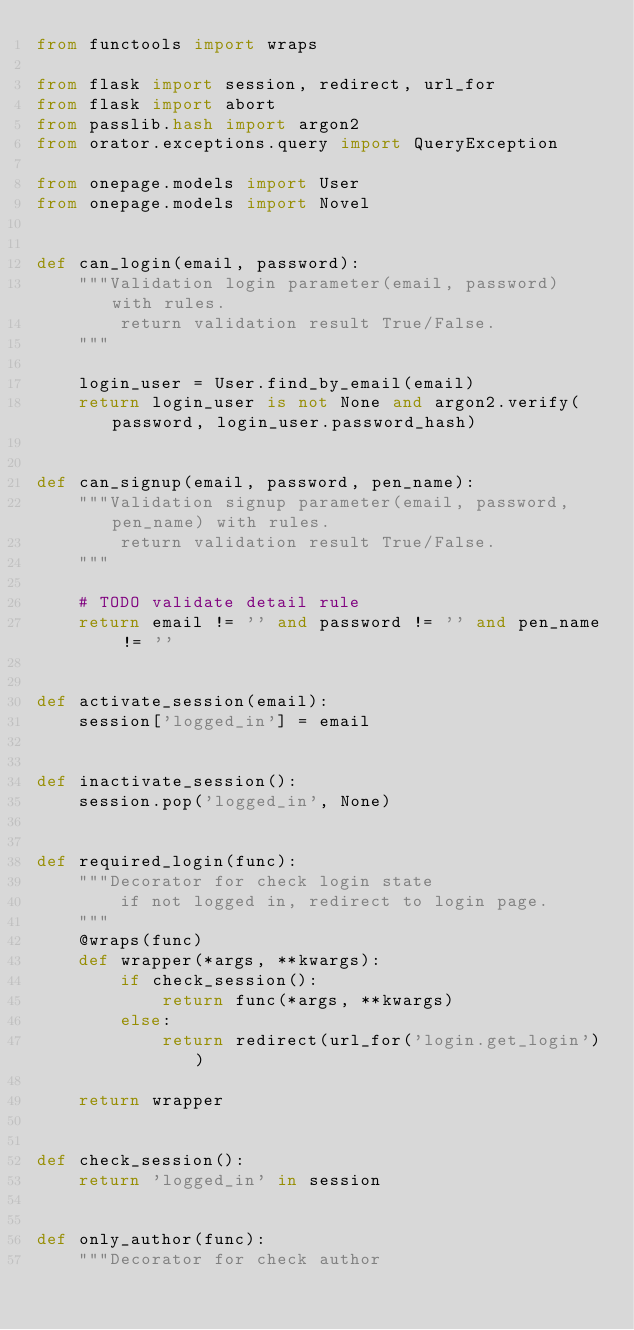Convert code to text. <code><loc_0><loc_0><loc_500><loc_500><_Python_>from functools import wraps

from flask import session, redirect, url_for
from flask import abort
from passlib.hash import argon2
from orator.exceptions.query import QueryException

from onepage.models import User
from onepage.models import Novel


def can_login(email, password):
    """Validation login parameter(email, password) with rules.
        return validation result True/False.
    """

    login_user = User.find_by_email(email)
    return login_user is not None and argon2.verify(password, login_user.password_hash)


def can_signup(email, password, pen_name):
    """Validation signup parameter(email, password, pen_name) with rules.
        return validation result True/False.
    """

    # TODO validate detail rule
    return email != '' and password != '' and pen_name != ''


def activate_session(email):
    session['logged_in'] = email


def inactivate_session():
    session.pop('logged_in', None)


def required_login(func):
    """Decorator for check login state
        if not logged in, redirect to login page.
    """
    @wraps(func)
    def wrapper(*args, **kwargs):
        if check_session():
            return func(*args, **kwargs)
        else:
            return redirect(url_for('login.get_login'))

    return wrapper


def check_session():
    return 'logged_in' in session


def only_author(func):
    """Decorator for check author</code> 